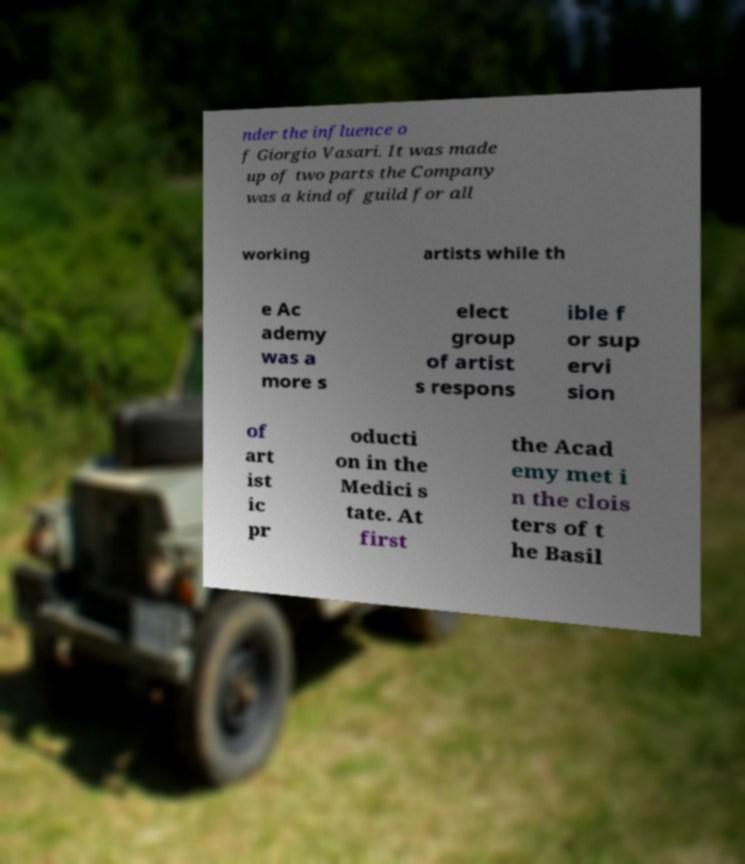Please identify and transcribe the text found in this image. nder the influence o f Giorgio Vasari. It was made up of two parts the Company was a kind of guild for all working artists while th e Ac ademy was a more s elect group of artist s respons ible f or sup ervi sion of art ist ic pr oducti on in the Medici s tate. At first the Acad emy met i n the clois ters of t he Basil 